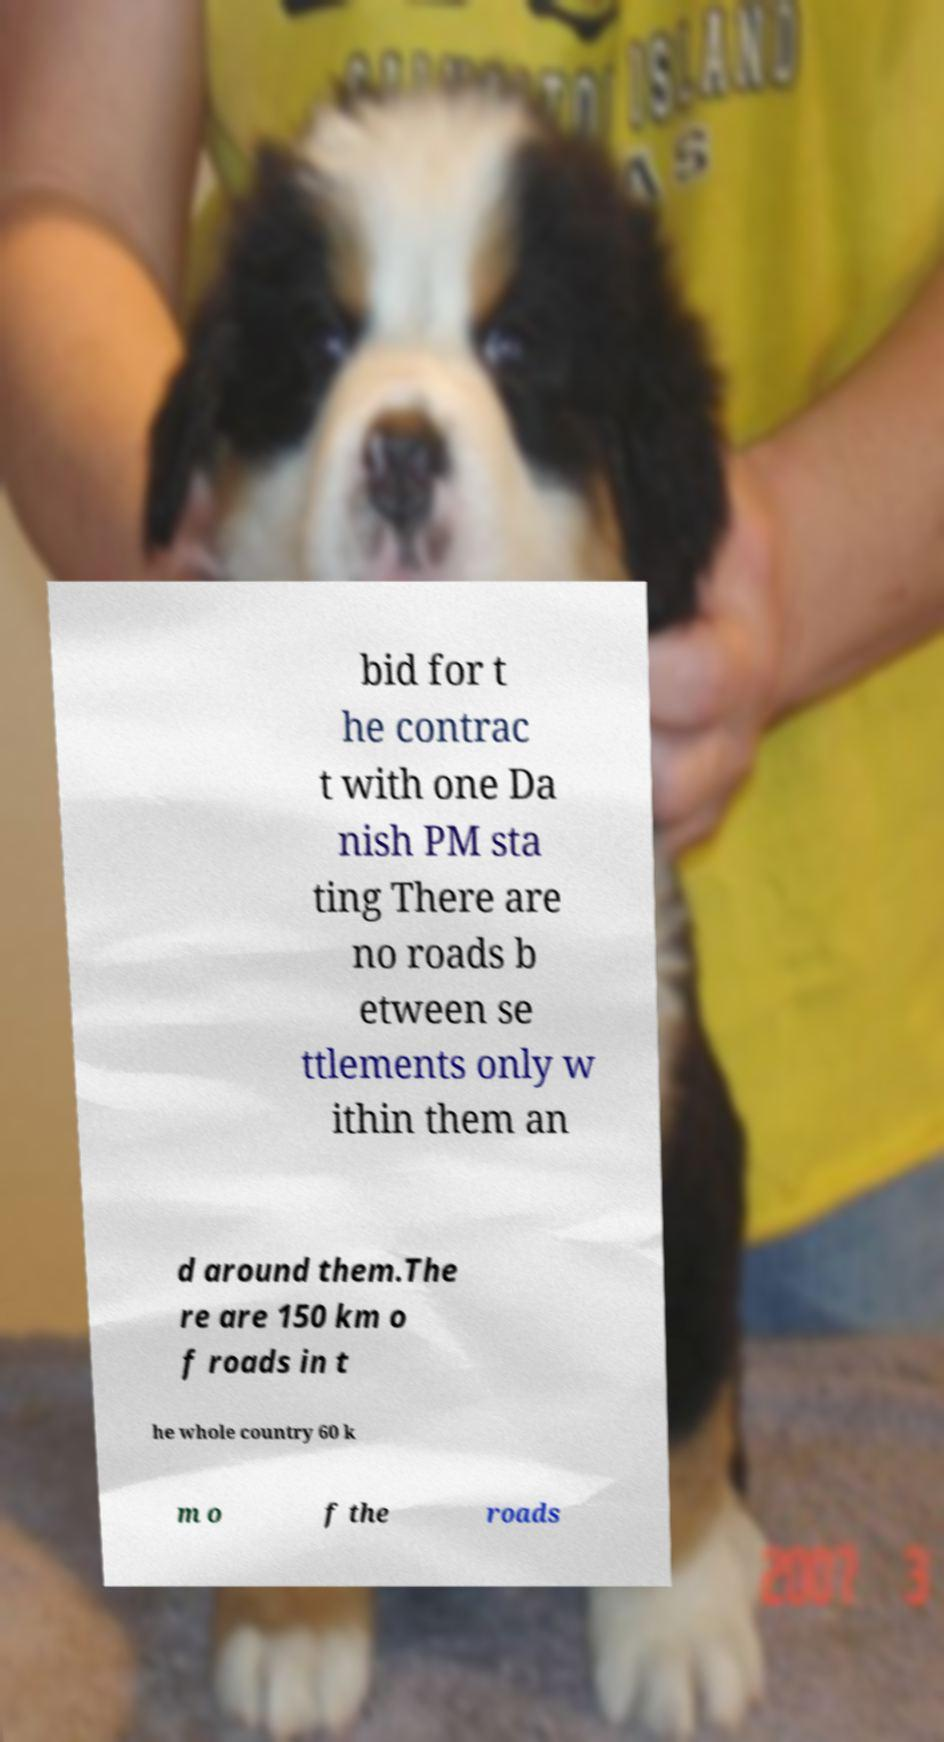Can you read and provide the text displayed in the image?This photo seems to have some interesting text. Can you extract and type it out for me? bid for t he contrac t with one Da nish PM sta ting There are no roads b etween se ttlements only w ithin them an d around them.The re are 150 km o f roads in t he whole country 60 k m o f the roads 